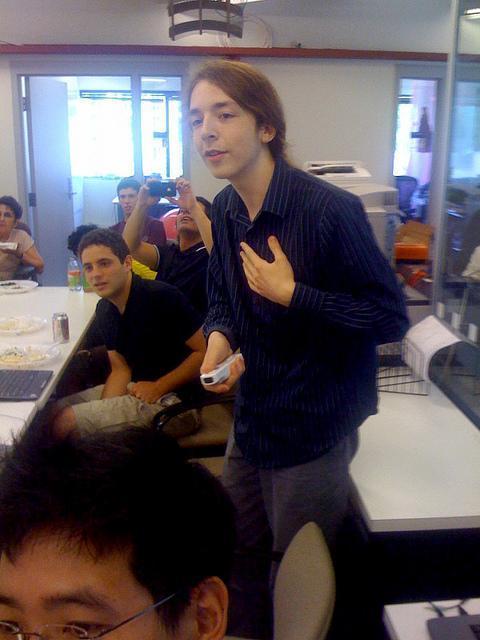How many dining tables are there?
Give a very brief answer. 2. How many people can be seen?
Give a very brief answer. 6. How many chairs are there?
Give a very brief answer. 2. How many black cars are there?
Give a very brief answer. 0. 